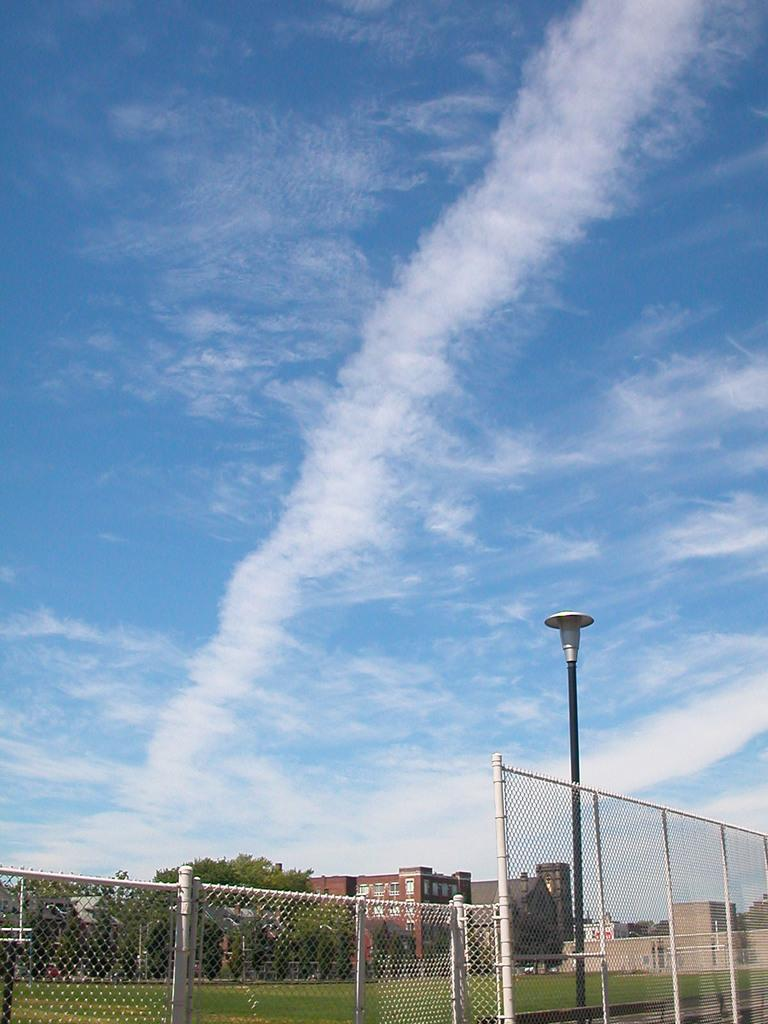What type of structure is on the grass floor in the image? There is a fencing on the grass floor in the image. What is attached to the pole in the image? There is a light attached to the pole in the image. What type of buildings can be seen in the image? There are houses in the image. What type of vegetation is present in the image? There are trees in the image. Can you see a nest in the image? There is no nest present in the image. What sense is being used by the trees in the image? Trees do not have senses; they are inanimate objects. 